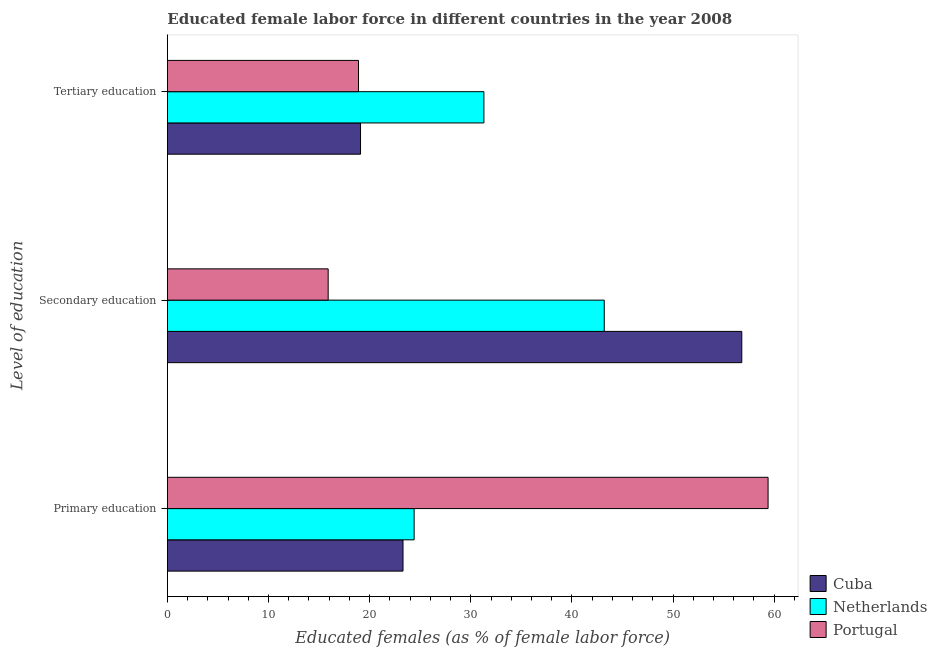How many different coloured bars are there?
Provide a short and direct response. 3. How many groups of bars are there?
Give a very brief answer. 3. How many bars are there on the 1st tick from the top?
Offer a terse response. 3. What is the label of the 2nd group of bars from the top?
Give a very brief answer. Secondary education. What is the percentage of female labor force who received primary education in Portugal?
Your answer should be compact. 59.4. Across all countries, what is the maximum percentage of female labor force who received primary education?
Make the answer very short. 59.4. Across all countries, what is the minimum percentage of female labor force who received tertiary education?
Your answer should be very brief. 18.9. In which country was the percentage of female labor force who received secondary education maximum?
Make the answer very short. Cuba. In which country was the percentage of female labor force who received primary education minimum?
Provide a short and direct response. Cuba. What is the total percentage of female labor force who received primary education in the graph?
Offer a terse response. 107.1. What is the difference between the percentage of female labor force who received tertiary education in Cuba and that in Netherlands?
Offer a terse response. -12.2. What is the difference between the percentage of female labor force who received primary education in Netherlands and the percentage of female labor force who received secondary education in Cuba?
Make the answer very short. -32.4. What is the average percentage of female labor force who received secondary education per country?
Give a very brief answer. 38.63. What is the difference between the percentage of female labor force who received primary education and percentage of female labor force who received secondary education in Netherlands?
Keep it short and to the point. -18.8. In how many countries, is the percentage of female labor force who received secondary education greater than 54 %?
Your response must be concise. 1. What is the ratio of the percentage of female labor force who received tertiary education in Netherlands to that in Portugal?
Offer a very short reply. 1.66. Is the difference between the percentage of female labor force who received secondary education in Netherlands and Cuba greater than the difference between the percentage of female labor force who received primary education in Netherlands and Cuba?
Offer a very short reply. No. What is the difference between the highest and the second highest percentage of female labor force who received primary education?
Offer a terse response. 35. What is the difference between the highest and the lowest percentage of female labor force who received secondary education?
Your response must be concise. 40.9. In how many countries, is the percentage of female labor force who received secondary education greater than the average percentage of female labor force who received secondary education taken over all countries?
Provide a succinct answer. 2. What does the 1st bar from the bottom in Tertiary education represents?
Offer a terse response. Cuba. Is it the case that in every country, the sum of the percentage of female labor force who received primary education and percentage of female labor force who received secondary education is greater than the percentage of female labor force who received tertiary education?
Offer a terse response. Yes. How many bars are there?
Provide a short and direct response. 9. How many countries are there in the graph?
Offer a very short reply. 3. What is the difference between two consecutive major ticks on the X-axis?
Provide a succinct answer. 10. Are the values on the major ticks of X-axis written in scientific E-notation?
Offer a very short reply. No. Does the graph contain any zero values?
Ensure brevity in your answer.  No. Does the graph contain grids?
Offer a very short reply. No. How many legend labels are there?
Your response must be concise. 3. What is the title of the graph?
Ensure brevity in your answer.  Educated female labor force in different countries in the year 2008. What is the label or title of the X-axis?
Offer a very short reply. Educated females (as % of female labor force). What is the label or title of the Y-axis?
Offer a terse response. Level of education. What is the Educated females (as % of female labor force) of Cuba in Primary education?
Your response must be concise. 23.3. What is the Educated females (as % of female labor force) of Netherlands in Primary education?
Provide a succinct answer. 24.4. What is the Educated females (as % of female labor force) of Portugal in Primary education?
Make the answer very short. 59.4. What is the Educated females (as % of female labor force) in Cuba in Secondary education?
Ensure brevity in your answer.  56.8. What is the Educated females (as % of female labor force) of Netherlands in Secondary education?
Give a very brief answer. 43.2. What is the Educated females (as % of female labor force) in Portugal in Secondary education?
Offer a very short reply. 15.9. What is the Educated females (as % of female labor force) of Cuba in Tertiary education?
Give a very brief answer. 19.1. What is the Educated females (as % of female labor force) of Netherlands in Tertiary education?
Ensure brevity in your answer.  31.3. What is the Educated females (as % of female labor force) of Portugal in Tertiary education?
Your answer should be very brief. 18.9. Across all Level of education, what is the maximum Educated females (as % of female labor force) in Cuba?
Offer a terse response. 56.8. Across all Level of education, what is the maximum Educated females (as % of female labor force) in Netherlands?
Provide a short and direct response. 43.2. Across all Level of education, what is the maximum Educated females (as % of female labor force) of Portugal?
Your response must be concise. 59.4. Across all Level of education, what is the minimum Educated females (as % of female labor force) in Cuba?
Give a very brief answer. 19.1. Across all Level of education, what is the minimum Educated females (as % of female labor force) of Netherlands?
Offer a terse response. 24.4. Across all Level of education, what is the minimum Educated females (as % of female labor force) of Portugal?
Ensure brevity in your answer.  15.9. What is the total Educated females (as % of female labor force) in Cuba in the graph?
Provide a short and direct response. 99.2. What is the total Educated females (as % of female labor force) in Netherlands in the graph?
Provide a short and direct response. 98.9. What is the total Educated females (as % of female labor force) of Portugal in the graph?
Make the answer very short. 94.2. What is the difference between the Educated females (as % of female labor force) of Cuba in Primary education and that in Secondary education?
Ensure brevity in your answer.  -33.5. What is the difference between the Educated females (as % of female labor force) in Netherlands in Primary education and that in Secondary education?
Keep it short and to the point. -18.8. What is the difference between the Educated females (as % of female labor force) in Portugal in Primary education and that in Secondary education?
Provide a succinct answer. 43.5. What is the difference between the Educated females (as % of female labor force) in Cuba in Primary education and that in Tertiary education?
Offer a terse response. 4.2. What is the difference between the Educated females (as % of female labor force) of Netherlands in Primary education and that in Tertiary education?
Offer a terse response. -6.9. What is the difference between the Educated females (as % of female labor force) in Portugal in Primary education and that in Tertiary education?
Make the answer very short. 40.5. What is the difference between the Educated females (as % of female labor force) of Cuba in Secondary education and that in Tertiary education?
Provide a succinct answer. 37.7. What is the difference between the Educated females (as % of female labor force) in Cuba in Primary education and the Educated females (as % of female labor force) in Netherlands in Secondary education?
Offer a terse response. -19.9. What is the difference between the Educated females (as % of female labor force) in Netherlands in Primary education and the Educated females (as % of female labor force) in Portugal in Secondary education?
Provide a succinct answer. 8.5. What is the difference between the Educated females (as % of female labor force) in Cuba in Primary education and the Educated females (as % of female labor force) in Netherlands in Tertiary education?
Offer a terse response. -8. What is the difference between the Educated females (as % of female labor force) in Netherlands in Primary education and the Educated females (as % of female labor force) in Portugal in Tertiary education?
Offer a very short reply. 5.5. What is the difference between the Educated females (as % of female labor force) of Cuba in Secondary education and the Educated females (as % of female labor force) of Portugal in Tertiary education?
Your answer should be very brief. 37.9. What is the difference between the Educated females (as % of female labor force) of Netherlands in Secondary education and the Educated females (as % of female labor force) of Portugal in Tertiary education?
Provide a short and direct response. 24.3. What is the average Educated females (as % of female labor force) of Cuba per Level of education?
Your answer should be compact. 33.07. What is the average Educated females (as % of female labor force) of Netherlands per Level of education?
Offer a terse response. 32.97. What is the average Educated females (as % of female labor force) of Portugal per Level of education?
Give a very brief answer. 31.4. What is the difference between the Educated females (as % of female labor force) of Cuba and Educated females (as % of female labor force) of Netherlands in Primary education?
Ensure brevity in your answer.  -1.1. What is the difference between the Educated females (as % of female labor force) in Cuba and Educated females (as % of female labor force) in Portugal in Primary education?
Ensure brevity in your answer.  -36.1. What is the difference between the Educated females (as % of female labor force) of Netherlands and Educated females (as % of female labor force) of Portugal in Primary education?
Your answer should be compact. -35. What is the difference between the Educated females (as % of female labor force) of Cuba and Educated females (as % of female labor force) of Portugal in Secondary education?
Your answer should be very brief. 40.9. What is the difference between the Educated females (as % of female labor force) in Netherlands and Educated females (as % of female labor force) in Portugal in Secondary education?
Give a very brief answer. 27.3. What is the difference between the Educated females (as % of female labor force) in Cuba and Educated females (as % of female labor force) in Netherlands in Tertiary education?
Your answer should be very brief. -12.2. What is the ratio of the Educated females (as % of female labor force) in Cuba in Primary education to that in Secondary education?
Provide a short and direct response. 0.41. What is the ratio of the Educated females (as % of female labor force) of Netherlands in Primary education to that in Secondary education?
Your answer should be very brief. 0.56. What is the ratio of the Educated females (as % of female labor force) of Portugal in Primary education to that in Secondary education?
Your response must be concise. 3.74. What is the ratio of the Educated females (as % of female labor force) of Cuba in Primary education to that in Tertiary education?
Offer a terse response. 1.22. What is the ratio of the Educated females (as % of female labor force) of Netherlands in Primary education to that in Tertiary education?
Your answer should be very brief. 0.78. What is the ratio of the Educated females (as % of female labor force) in Portugal in Primary education to that in Tertiary education?
Keep it short and to the point. 3.14. What is the ratio of the Educated females (as % of female labor force) in Cuba in Secondary education to that in Tertiary education?
Provide a succinct answer. 2.97. What is the ratio of the Educated females (as % of female labor force) in Netherlands in Secondary education to that in Tertiary education?
Your answer should be very brief. 1.38. What is the ratio of the Educated females (as % of female labor force) in Portugal in Secondary education to that in Tertiary education?
Offer a terse response. 0.84. What is the difference between the highest and the second highest Educated females (as % of female labor force) of Cuba?
Your answer should be very brief. 33.5. What is the difference between the highest and the second highest Educated females (as % of female labor force) of Netherlands?
Offer a terse response. 11.9. What is the difference between the highest and the second highest Educated females (as % of female labor force) of Portugal?
Give a very brief answer. 40.5. What is the difference between the highest and the lowest Educated females (as % of female labor force) in Cuba?
Offer a very short reply. 37.7. What is the difference between the highest and the lowest Educated females (as % of female labor force) of Netherlands?
Make the answer very short. 18.8. What is the difference between the highest and the lowest Educated females (as % of female labor force) of Portugal?
Offer a very short reply. 43.5. 